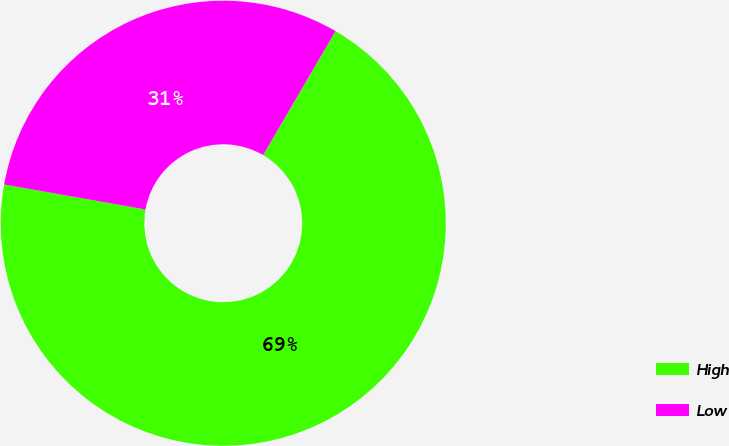Convert chart. <chart><loc_0><loc_0><loc_500><loc_500><pie_chart><fcel>High<fcel>Low<nl><fcel>69.37%<fcel>30.63%<nl></chart> 